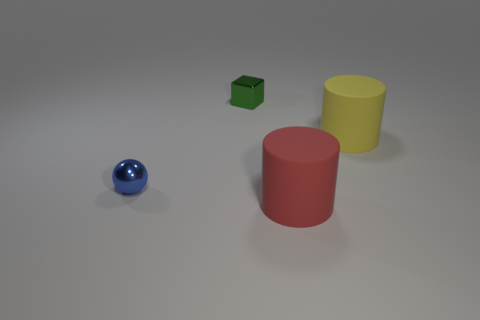What is the shape of the tiny shiny thing to the left of the green block?
Offer a very short reply. Sphere. Is there a yellow cylinder that has the same material as the cube?
Your answer should be compact. No. Do the blue metal thing and the green metallic cube have the same size?
Offer a terse response. Yes. How many cylinders are either metallic things or big cyan rubber things?
Offer a very short reply. 0. What number of big red matte objects are the same shape as the large yellow rubber object?
Make the answer very short. 1. Is the number of metallic objects that are behind the small green thing greater than the number of things behind the yellow rubber thing?
Keep it short and to the point. No. There is a small shiny thing that is on the right side of the ball; does it have the same color as the metal sphere?
Your answer should be compact. No. What size is the red thing?
Keep it short and to the point. Large. There is another thing that is the same size as the green thing; what is its material?
Provide a short and direct response. Metal. There is a thing in front of the small blue metal thing; what is its color?
Give a very brief answer. Red. 